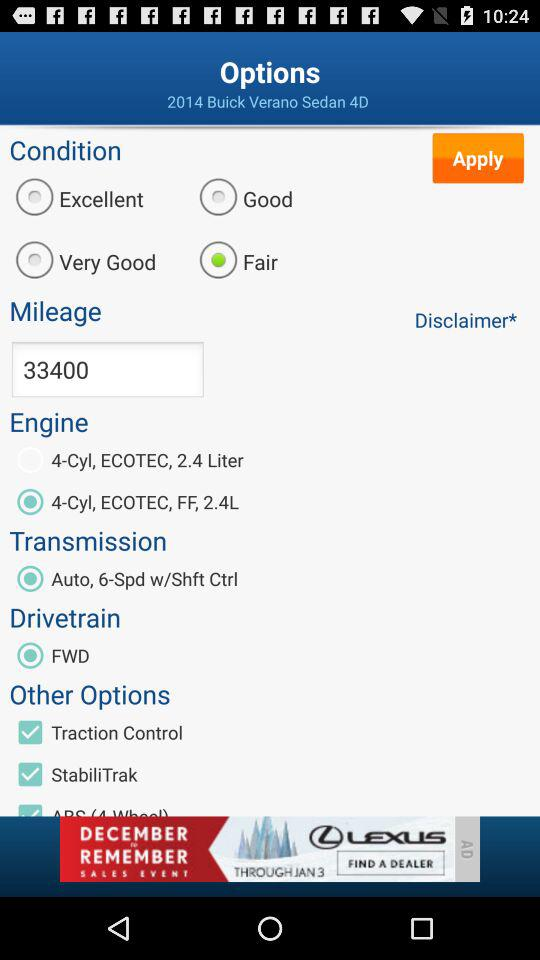What is the transmission system? The transmission system is "Auto, 6-Spd w/Shft Ctrl". 